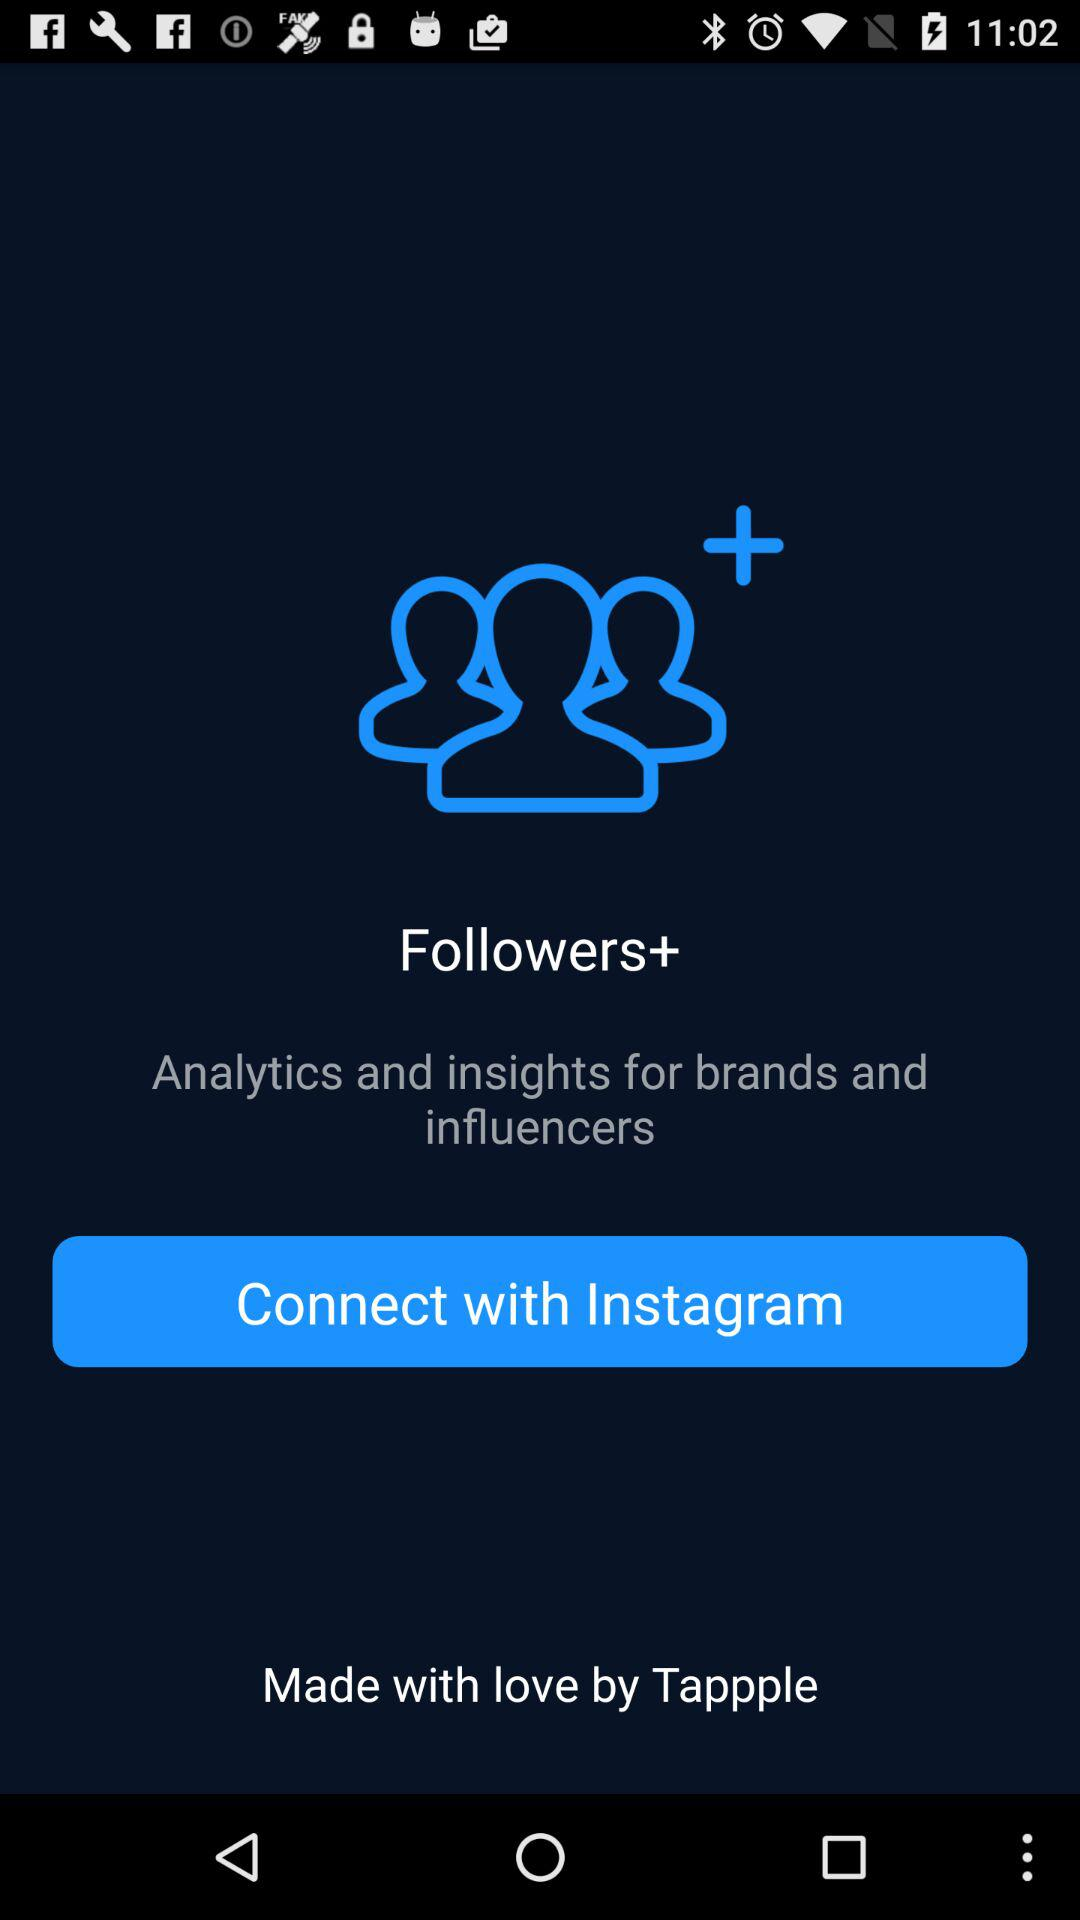Which app can we connect with? You can connect with "Instagram". 